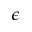Convert formula to latex. <formula><loc_0><loc_0><loc_500><loc_500>\epsilon</formula> 